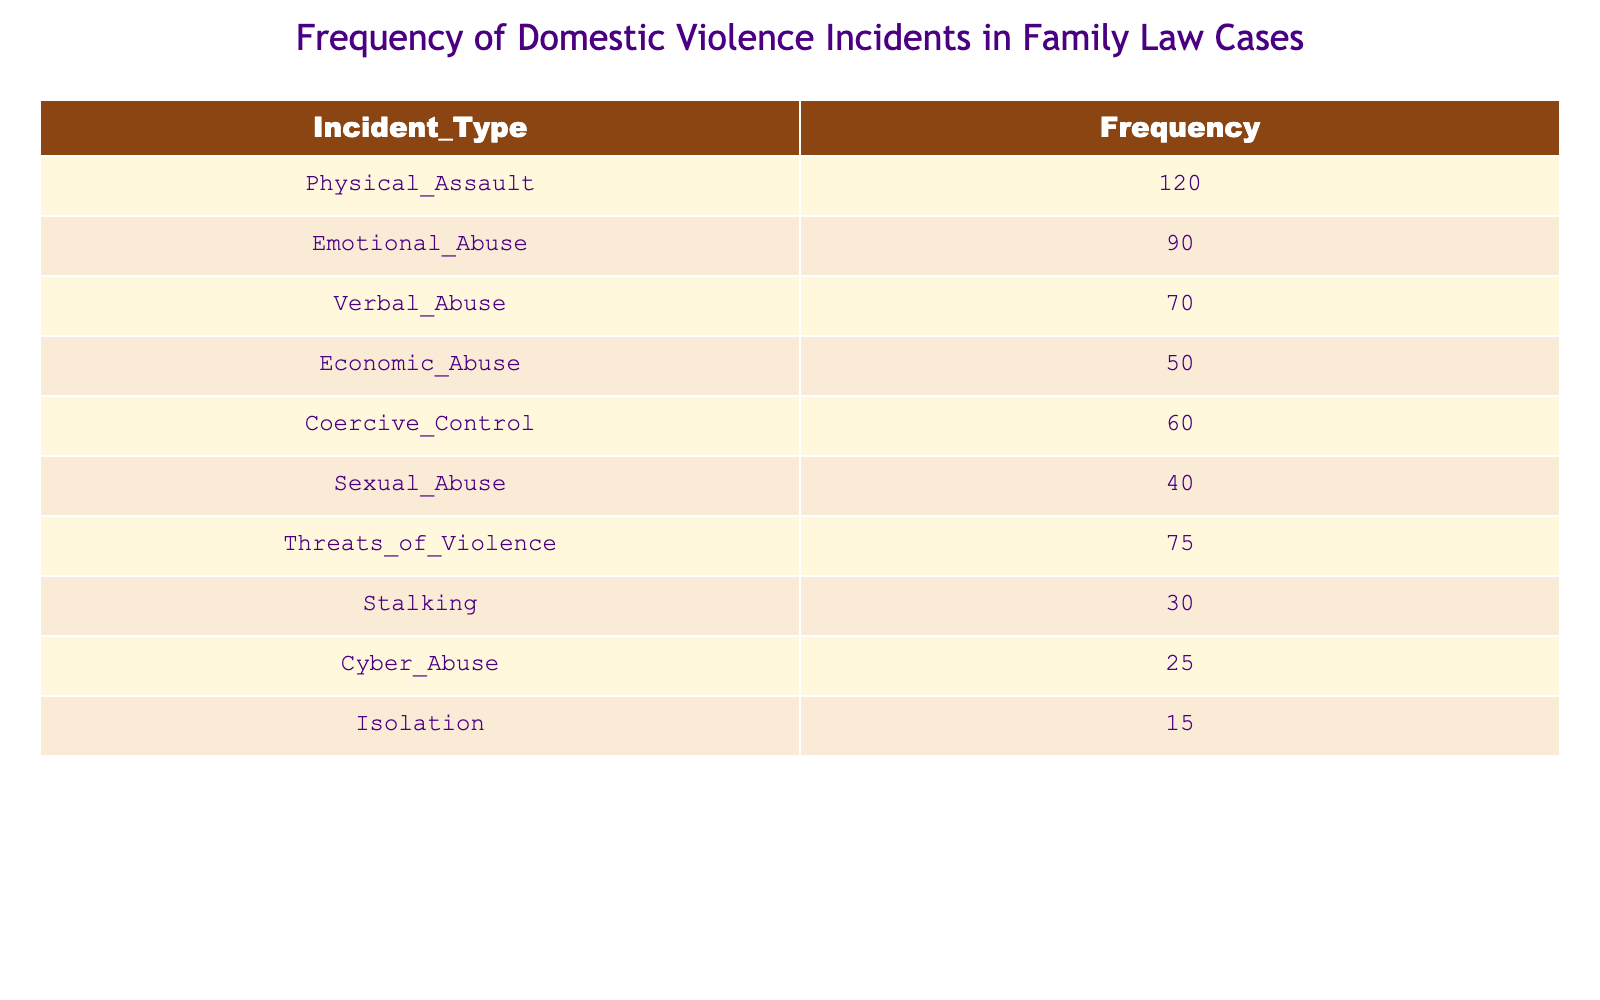What is the frequency of Physical Assault incidents? The table lists Physical Assault with a frequency of 120 incidents.
Answer: 120 Which type of domestic violence has the lowest frequency? By reviewing the frequencies, Isolation has the lowest frequency at 15 incidents.
Answer: 15 How many incidents of Emotional Abuse and Verbal Abuse combined? The frequency of Emotional Abuse is 90, and Verbal Abuse is 70. Adding these gives 90 + 70 = 160.
Answer: 160 Is it true that the frequency of Sexual Abuse is greater than Stalking? Sexual Abuse has a frequency of 40, while Stalking has a frequency of 30. Since 40 is greater than 30, the statement is true.
Answer: Yes What is the total frequency of all incident types listed in the table? We sum each frequency: 120 + 90 + 70 + 50 + 60 + 40 + 75 + 30 + 25 + 15 = 570. Thus, the total frequency is 570.
Answer: 570 How many more incidents of Physical Assault are reported than Sexual Abuse? The frequency of Physical Assault is 120, and Sexual Abuse is 40. Subtracting gives 120 - 40 = 80.
Answer: 80 Which incident type has a frequency greater than 60 but less than 100? Reviewing the table shows that Emotional Abuse (90) and Coercive Control (60) fit this criterion. Emotional Abuse is the only type that is strictly greater than 60 but less than 100.
Answer: 90 Are there any types of incidents with a frequency below 30? The frequencies below 30 are Stalking (30) and Cyber Abuse (25). Thus, there are incidents below 30.
Answer: Yes What is the average frequency of all incident types? We calculate the average by first finding the total frequency (570), then dividing by the number of incident types (10): 570 / 10 = 57.
Answer: 57 